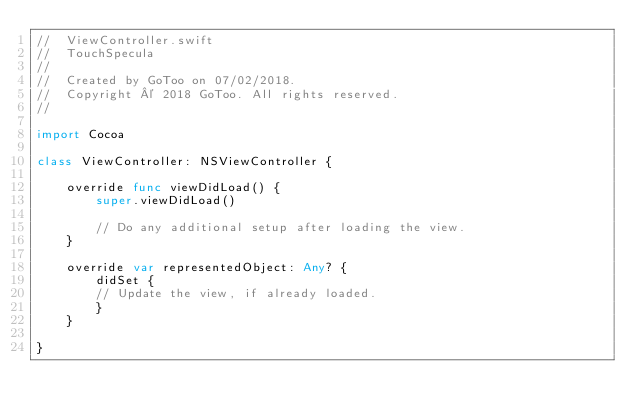Convert code to text. <code><loc_0><loc_0><loc_500><loc_500><_Swift_>//  ViewController.swift
//  TouchSpecula
//
//  Created by GoToo on 07/02/2018.
//  Copyright © 2018 GoToo. All rights reserved.
//

import Cocoa

class ViewController: NSViewController {

    override func viewDidLoad() {
        super.viewDidLoad()

        // Do any additional setup after loading the view.
    }

    override var representedObject: Any? {
        didSet {
        // Update the view, if already loaded.
        }
    }

}
</code> 